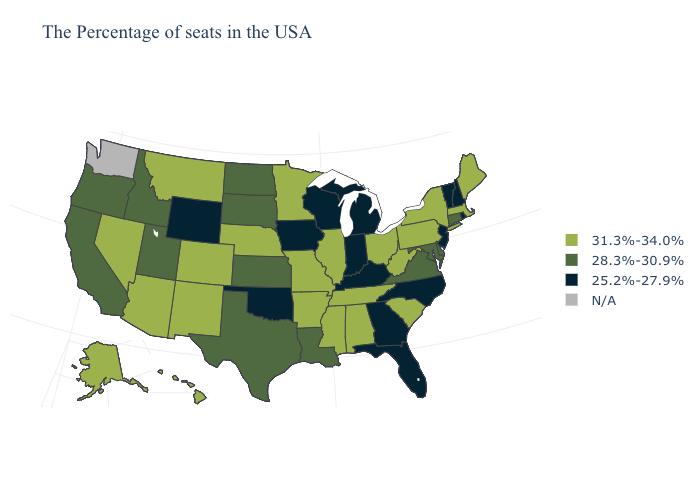What is the highest value in the USA?
Be succinct. 31.3%-34.0%. What is the value of Vermont?
Be succinct. 25.2%-27.9%. Name the states that have a value in the range 31.3%-34.0%?
Answer briefly. Maine, Massachusetts, New York, Pennsylvania, South Carolina, West Virginia, Ohio, Alabama, Tennessee, Illinois, Mississippi, Missouri, Arkansas, Minnesota, Nebraska, Colorado, New Mexico, Montana, Arizona, Nevada, Alaska, Hawaii. Does Rhode Island have the lowest value in the Northeast?
Write a very short answer. Yes. Name the states that have a value in the range 31.3%-34.0%?
Be succinct. Maine, Massachusetts, New York, Pennsylvania, South Carolina, West Virginia, Ohio, Alabama, Tennessee, Illinois, Mississippi, Missouri, Arkansas, Minnesota, Nebraska, Colorado, New Mexico, Montana, Arizona, Nevada, Alaska, Hawaii. What is the value of Delaware?
Keep it brief. 28.3%-30.9%. What is the lowest value in the USA?
Quick response, please. 25.2%-27.9%. Name the states that have a value in the range 25.2%-27.9%?
Quick response, please. Rhode Island, New Hampshire, Vermont, New Jersey, North Carolina, Florida, Georgia, Michigan, Kentucky, Indiana, Wisconsin, Iowa, Oklahoma, Wyoming. Which states hav the highest value in the West?
Quick response, please. Colorado, New Mexico, Montana, Arizona, Nevada, Alaska, Hawaii. Among the states that border Maryland , which have the highest value?
Quick response, please. Pennsylvania, West Virginia. What is the value of Maine?
Keep it brief. 31.3%-34.0%. What is the value of Virginia?
Quick response, please. 28.3%-30.9%. Does North Carolina have the lowest value in the USA?
Answer briefly. Yes. 